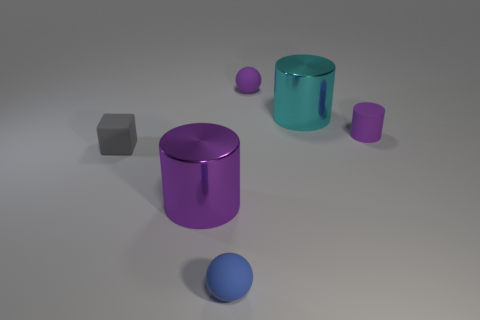Add 1 blue matte objects. How many objects exist? 7 Subtract all spheres. How many objects are left? 4 Subtract all purple cylinders. Subtract all big purple cylinders. How many objects are left? 3 Add 5 tiny purple rubber cylinders. How many tiny purple rubber cylinders are left? 6 Add 3 yellow metallic things. How many yellow metallic things exist? 3 Subtract 0 brown cubes. How many objects are left? 6 